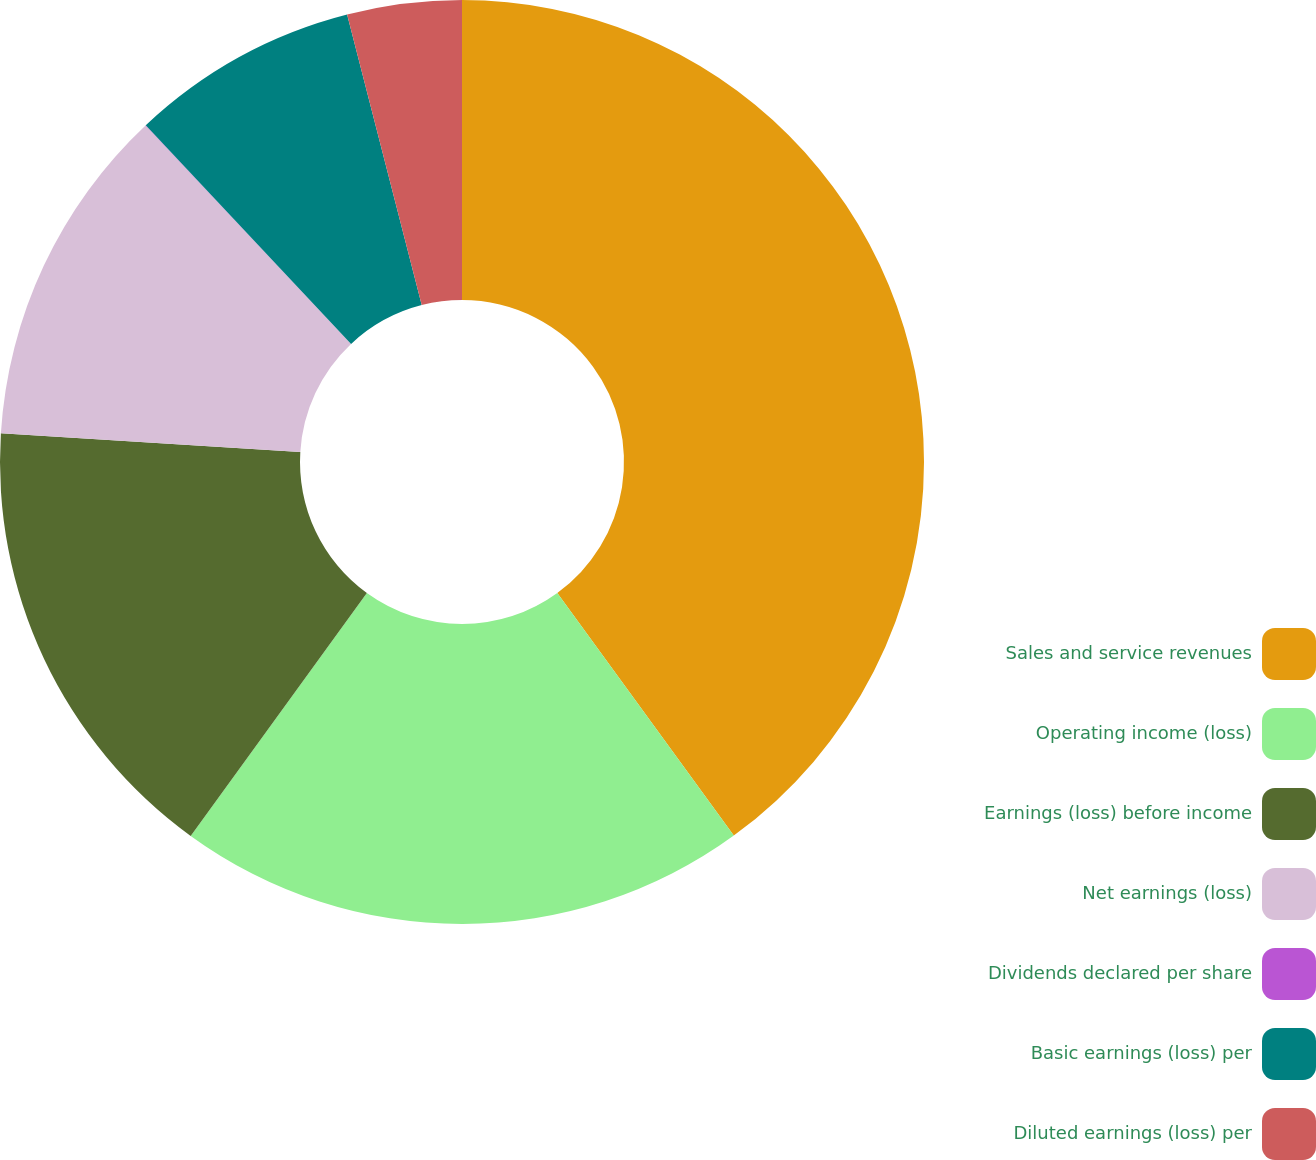Convert chart. <chart><loc_0><loc_0><loc_500><loc_500><pie_chart><fcel>Sales and service revenues<fcel>Operating income (loss)<fcel>Earnings (loss) before income<fcel>Net earnings (loss)<fcel>Dividends declared per share<fcel>Basic earnings (loss) per<fcel>Diluted earnings (loss) per<nl><fcel>39.99%<fcel>20.0%<fcel>16.0%<fcel>12.0%<fcel>0.01%<fcel>8.0%<fcel>4.0%<nl></chart> 